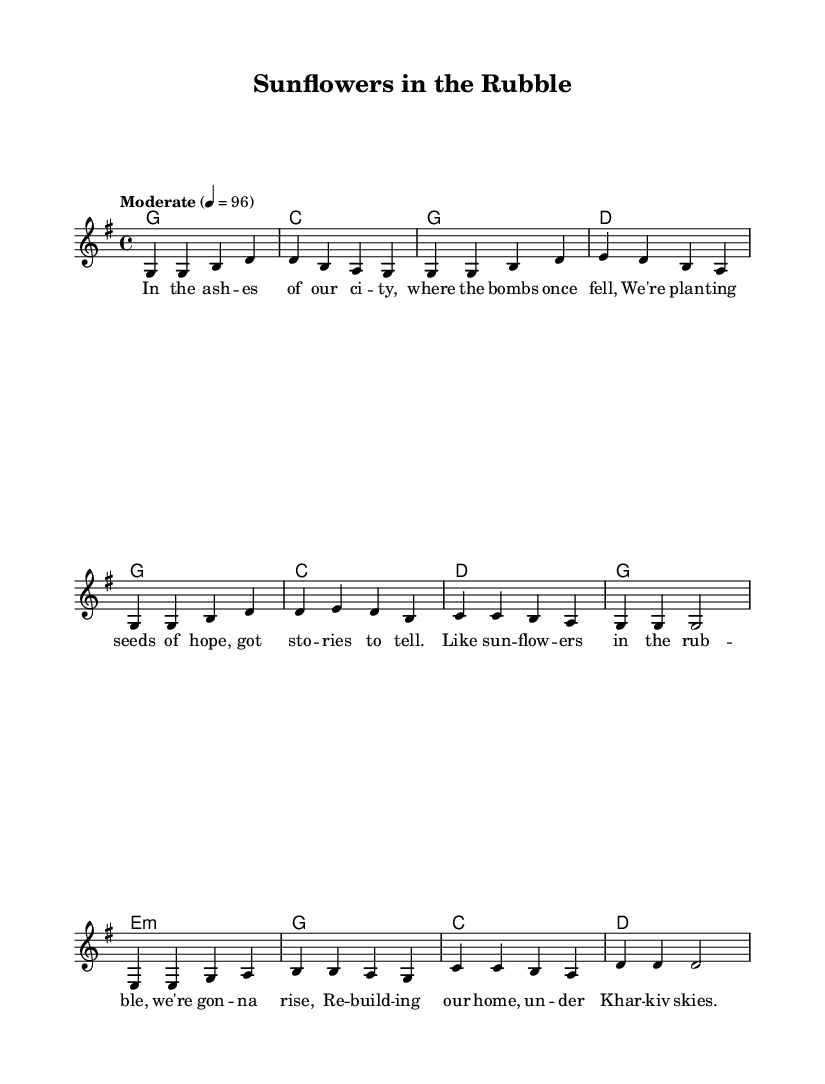What is the key signature of this music? The key signature is G major, which has one sharp (F#). You can determine the key signature by looking at the beginning of the score, where the key is notated.
Answer: G major What is the time signature of this music? The time signature is 4/4, meaning there are four beats in each measure and a quarter note gets one beat. This is shown at the beginning of the score right after the key signature.
Answer: 4/4 What is the tempo marking for this piece? The tempo marking is "Moderate" with a metronome marking of 96 beats per minute. This is indicated at the beginning of the score under the global settings.
Answer: Moderate How many measures are in the verse section? The verse section consists of four measures. You can count the measures in the melody section where the verse is located, which is clearly defined.
Answer: Four What are the first two notes of the melody in the chorus? The first two notes of the melody in the chorus are G and G. You can observe the melody line in the chorus section of the sheet music and identify the notes written down.
Answer: G and G Which chord follows the C chord in the harmony section during the chorus? The chord that follows the C chord in the harmony section during the chorus is D. This is determined by looking at the chord progression indicated in the harmony line associated with the chorus.
Answer: D What is the theme of the lyrics presented in the song? The theme of the lyrics relates to resilience and rebuilding after conflict, as indicated in both the verses and chorus reflecting hope and recovery. This is derived from analyzing the lyrical content presented throughout the sheet music.
Answer: Resilience 